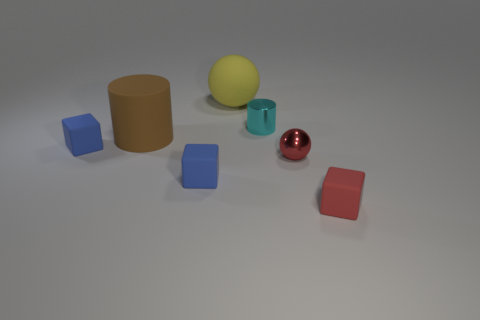Subtract all small blue matte blocks. How many blocks are left? 1 Add 1 tiny blue cubes. How many objects exist? 8 Subtract all yellow spheres. How many blue cubes are left? 2 Subtract all cyan cylinders. How many cylinders are left? 1 Subtract all green spheres. Subtract all green cylinders. How many spheres are left? 2 Subtract all spheres. How many objects are left? 5 Subtract 0 cyan spheres. How many objects are left? 7 Subtract all big cyan rubber blocks. Subtract all small blue blocks. How many objects are left? 5 Add 7 small cyan things. How many small cyan things are left? 8 Add 7 big things. How many big things exist? 9 